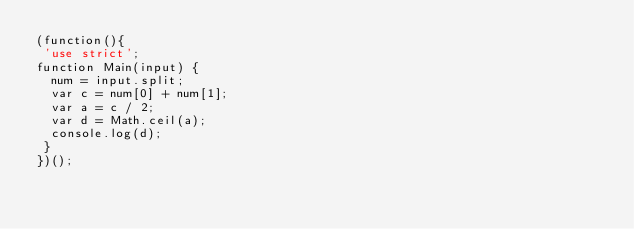<code> <loc_0><loc_0><loc_500><loc_500><_JavaScript_>(function(){
 'use strict';
function Main(input) {
  num = input.split;
  var c = num[0] + num[1];
  var a = c / 2;
  var d = Math.ceil(a);
  console.log(d);  
 }
})();</code> 